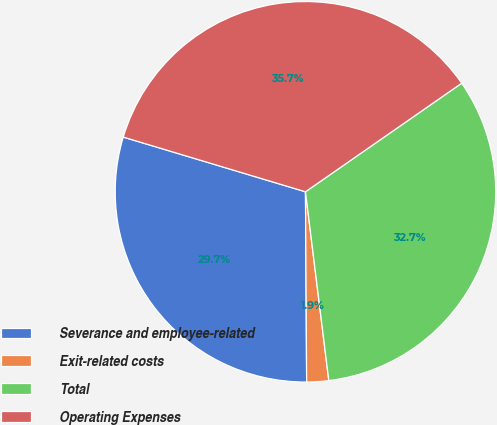Convert chart. <chart><loc_0><loc_0><loc_500><loc_500><pie_chart><fcel>Severance and employee-related<fcel>Exit-related costs<fcel>Total<fcel>Operating Expenses<nl><fcel>29.74%<fcel>1.86%<fcel>32.71%<fcel>35.69%<nl></chart> 